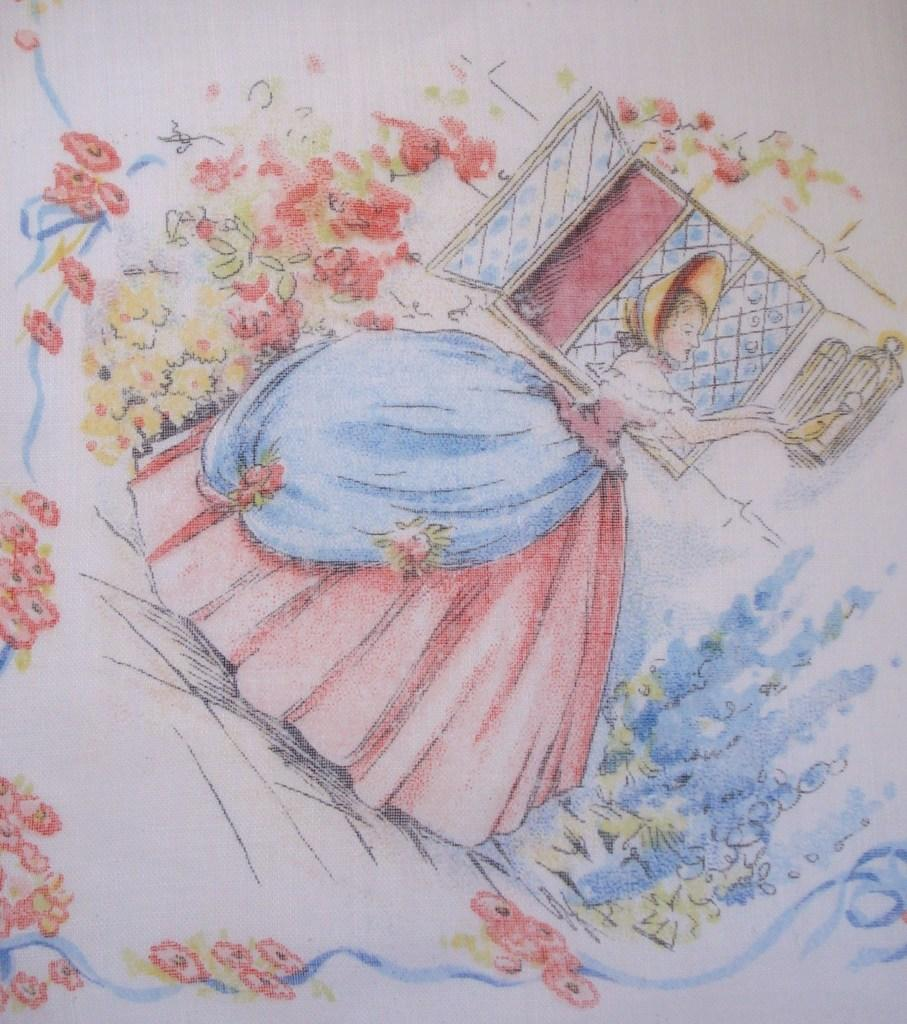What is depicted on the paper in the image? The image contains a drawing on paper. Can you describe the drawing in terms of color? The drawing has different colors. What elements are included in the drawing? There is a person, a window, and flowers in the drawing. How does the person in the drawing stretch in the middle of the carriage? There is no carriage present in the drawing, and the person is not stretching. 